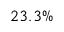Convert formula to latex. <formula><loc_0><loc_0><loc_500><loc_500>2 3 . 3 \%</formula> 